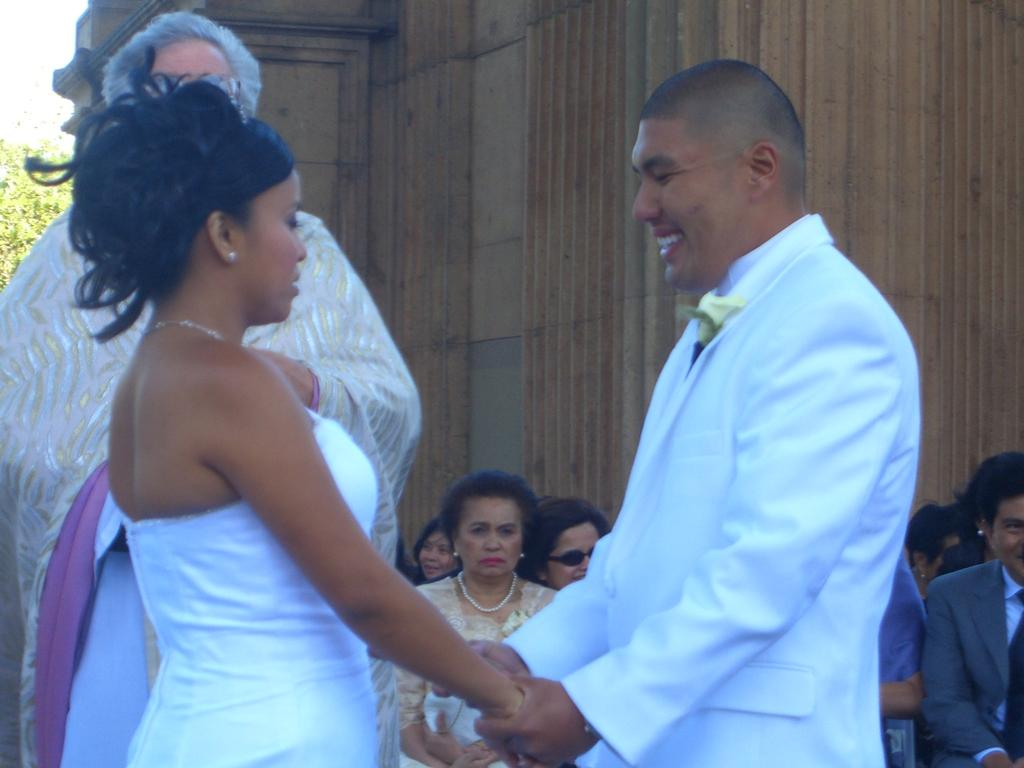How many people are in the image? There is a group of people in the image, but the exact number is not specified. What are the people in the image doing? Some people are seated, while others are standing. What can be seen in the background of the image? There is a building and trees in the background of the image. How many mice can be seen running along the line in the image? There are no mice or lines present in the image. What type of jewel is being worn by the person in the image? There is no person wearing a jewel in the image. 